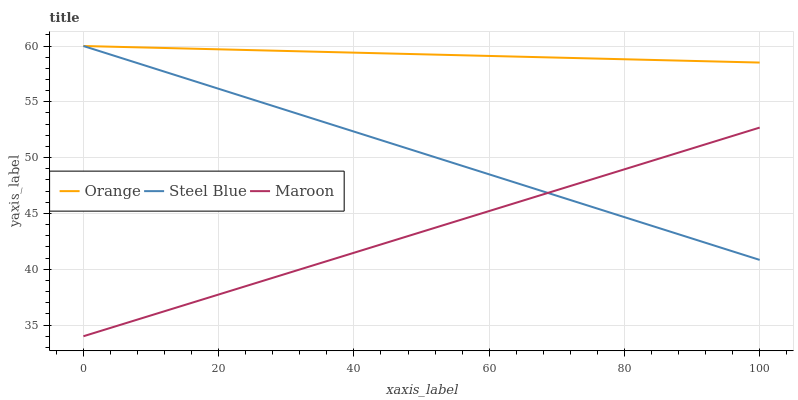Does Maroon have the minimum area under the curve?
Answer yes or no. Yes. Does Orange have the maximum area under the curve?
Answer yes or no. Yes. Does Steel Blue have the minimum area under the curve?
Answer yes or no. No. Does Steel Blue have the maximum area under the curve?
Answer yes or no. No. Is Orange the smoothest?
Answer yes or no. Yes. Is Maroon the roughest?
Answer yes or no. Yes. Is Steel Blue the smoothest?
Answer yes or no. No. Is Steel Blue the roughest?
Answer yes or no. No. Does Maroon have the lowest value?
Answer yes or no. Yes. Does Steel Blue have the lowest value?
Answer yes or no. No. Does Steel Blue have the highest value?
Answer yes or no. Yes. Does Maroon have the highest value?
Answer yes or no. No. Is Maroon less than Orange?
Answer yes or no. Yes. Is Orange greater than Maroon?
Answer yes or no. Yes. Does Maroon intersect Steel Blue?
Answer yes or no. Yes. Is Maroon less than Steel Blue?
Answer yes or no. No. Is Maroon greater than Steel Blue?
Answer yes or no. No. Does Maroon intersect Orange?
Answer yes or no. No. 